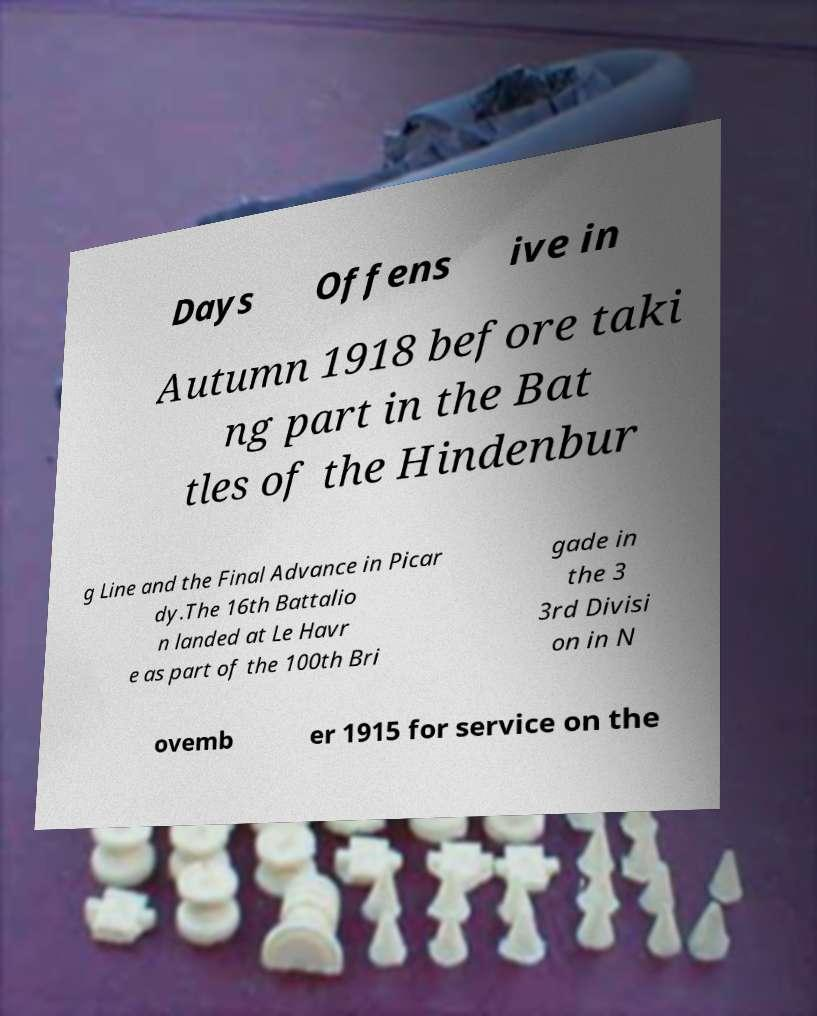I need the written content from this picture converted into text. Can you do that? Days Offens ive in Autumn 1918 before taki ng part in the Bat tles of the Hindenbur g Line and the Final Advance in Picar dy.The 16th Battalio n landed at Le Havr e as part of the 100th Bri gade in the 3 3rd Divisi on in N ovemb er 1915 for service on the 